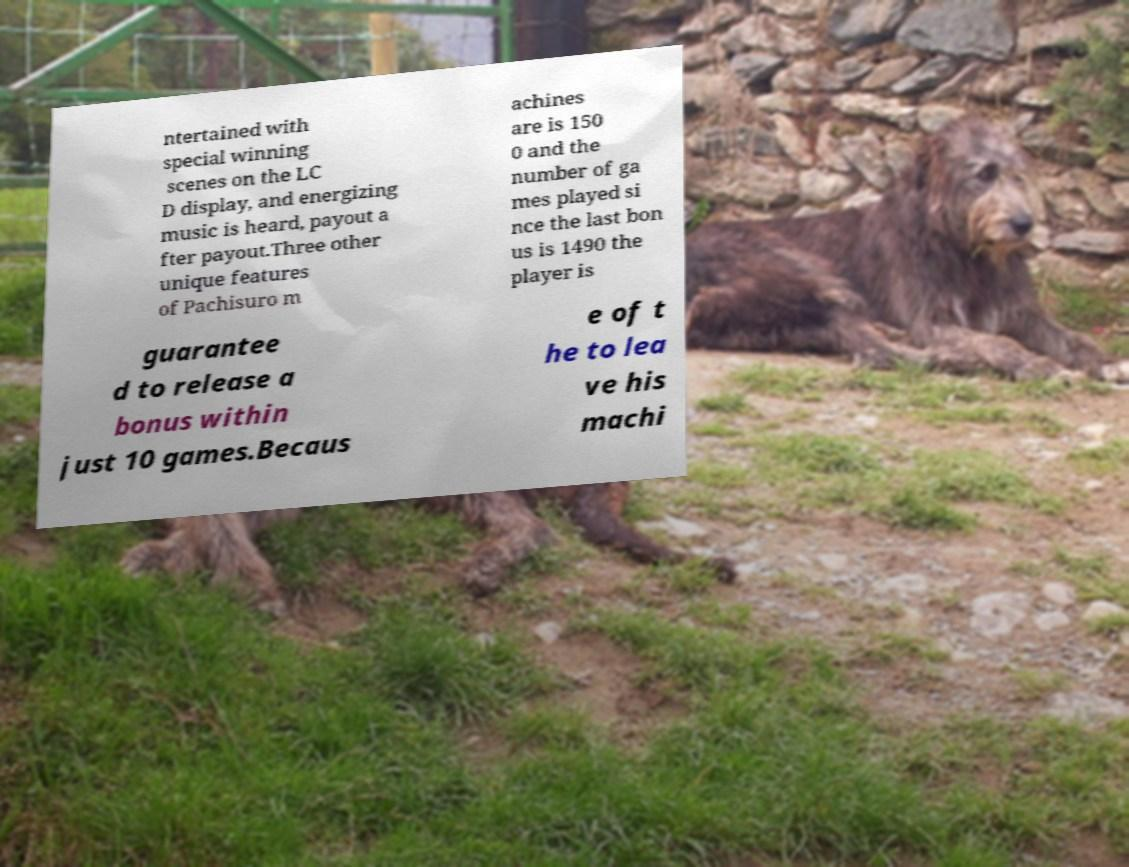Could you assist in decoding the text presented in this image and type it out clearly? ntertained with special winning scenes on the LC D display, and energizing music is heard, payout a fter payout.Three other unique features of Pachisuro m achines are is 150 0 and the number of ga mes played si nce the last bon us is 1490 the player is guarantee d to release a bonus within just 10 games.Becaus e of t he to lea ve his machi 